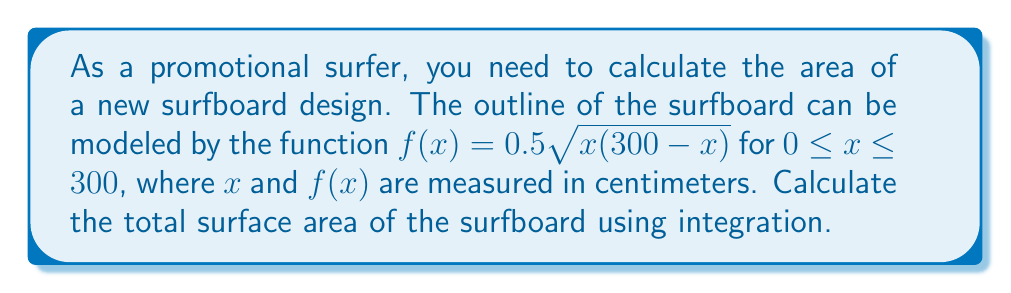What is the answer to this math problem? To find the area of the surfboard, we need to use the formula for the area of a surface of revolution:

$$A = 2\pi \int_{0}^{300} f(x)\sqrt{1 + [f'(x)]^2} dx$$

Let's break this down step by step:

1) First, we need to find $f'(x)$:
   $$f(x) = 0.5\sqrt{x(300-x)}$$
   $$f'(x) = 0.5 \cdot \frac{1}{2\sqrt{x(300-x)}} \cdot (300-2x)$$
   $$f'(x) = \frac{300-2x}{4\sqrt{x(300-x)}}$$

2) Now, let's substitute these into our area formula:
   $$A = 2\pi \int_{0}^{300} 0.5\sqrt{x(300-x)}\sqrt{1 + [\frac{300-2x}{4\sqrt{x(300-x)}}]^2} dx$$

3) Simplify the expression under the square root:
   $$1 + [\frac{300-2x}{4\sqrt{x(300-x)}}]^2 = \frac{16x(300-x) + (300-2x)^2}{16x(300-x)}$$
   $$= \frac{16x(300-x) + 90000 - 1200x + 4x^2}{16x(300-x)}$$
   $$= \frac{90000 + 4x^2 - 300x}{16x(300-x)} = \frac{90000}{16x(300-x)}$$

4) Substituting back into our integral:
   $$A = 2\pi \int_{0}^{300} 0.5\sqrt{x(300-x)}\sqrt{\frac{90000}{16x(300-x)}} dx$$
   $$= 2\pi \int_{0}^{300} 0.5\sqrt{x(300-x)}\frac{75}{\sqrt{x(300-x)}} dx$$
   $$= 75\pi \int_{0}^{300} dx$$

5) This simplifies to:
   $$A = 75\pi [x]_{0}^{300}$$
   $$= 75\pi (300 - 0) = 22500\pi$$

Therefore, the surface area of the surfboard is $22500\pi$ square centimeters.
Answer: $22500\pi$ square centimeters 